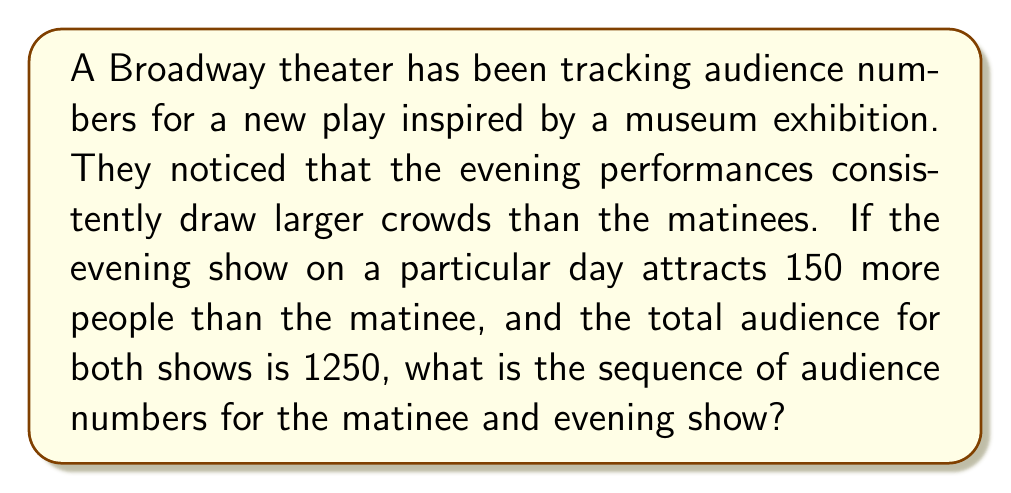Solve this math problem. Let's solve this step-by-step:

1) Let $x$ be the number of people attending the matinee.
2) Then, $x + 150$ is the number of people attending the evening show.
3) We know that the total audience for both shows is 1250, so we can write:

   $x + (x + 150) = 1250$

4) Simplify the equation:

   $2x + 150 = 1250$

5) Subtract 150 from both sides:

   $2x = 1100$

6) Divide both sides by 2:

   $x = 550$

7) So, the matinee audience is 550.
8) The evening audience is $550 + 150 = 700$.

Therefore, the sequence of audience numbers is:

$$(550, 700)$$

This forms an arithmetic sequence with a common difference of 150.
Answer: $(550, 700)$ 